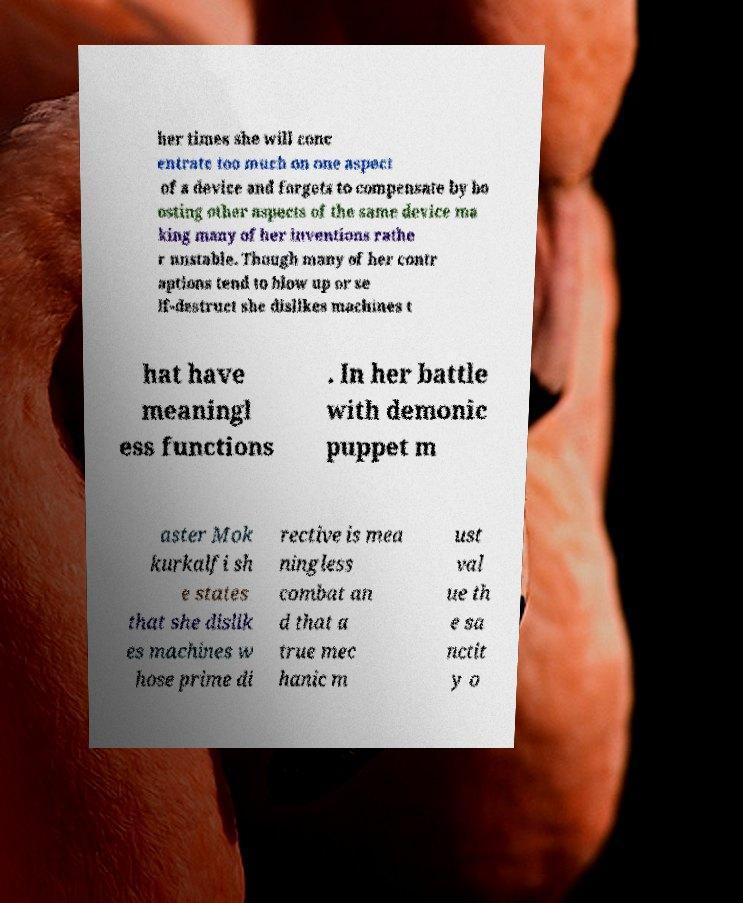Please read and relay the text visible in this image. What does it say? her times she will conc entrate too much on one aspect of a device and forgets to compensate by bo osting other aspects of the same device ma king many of her inventions rathe r unstable. Though many of her contr aptions tend to blow up or se lf-destruct she dislikes machines t hat have meaningl ess functions . In her battle with demonic puppet m aster Mok kurkalfi sh e states that she dislik es machines w hose prime di rective is mea ningless combat an d that a true mec hanic m ust val ue th e sa nctit y o 